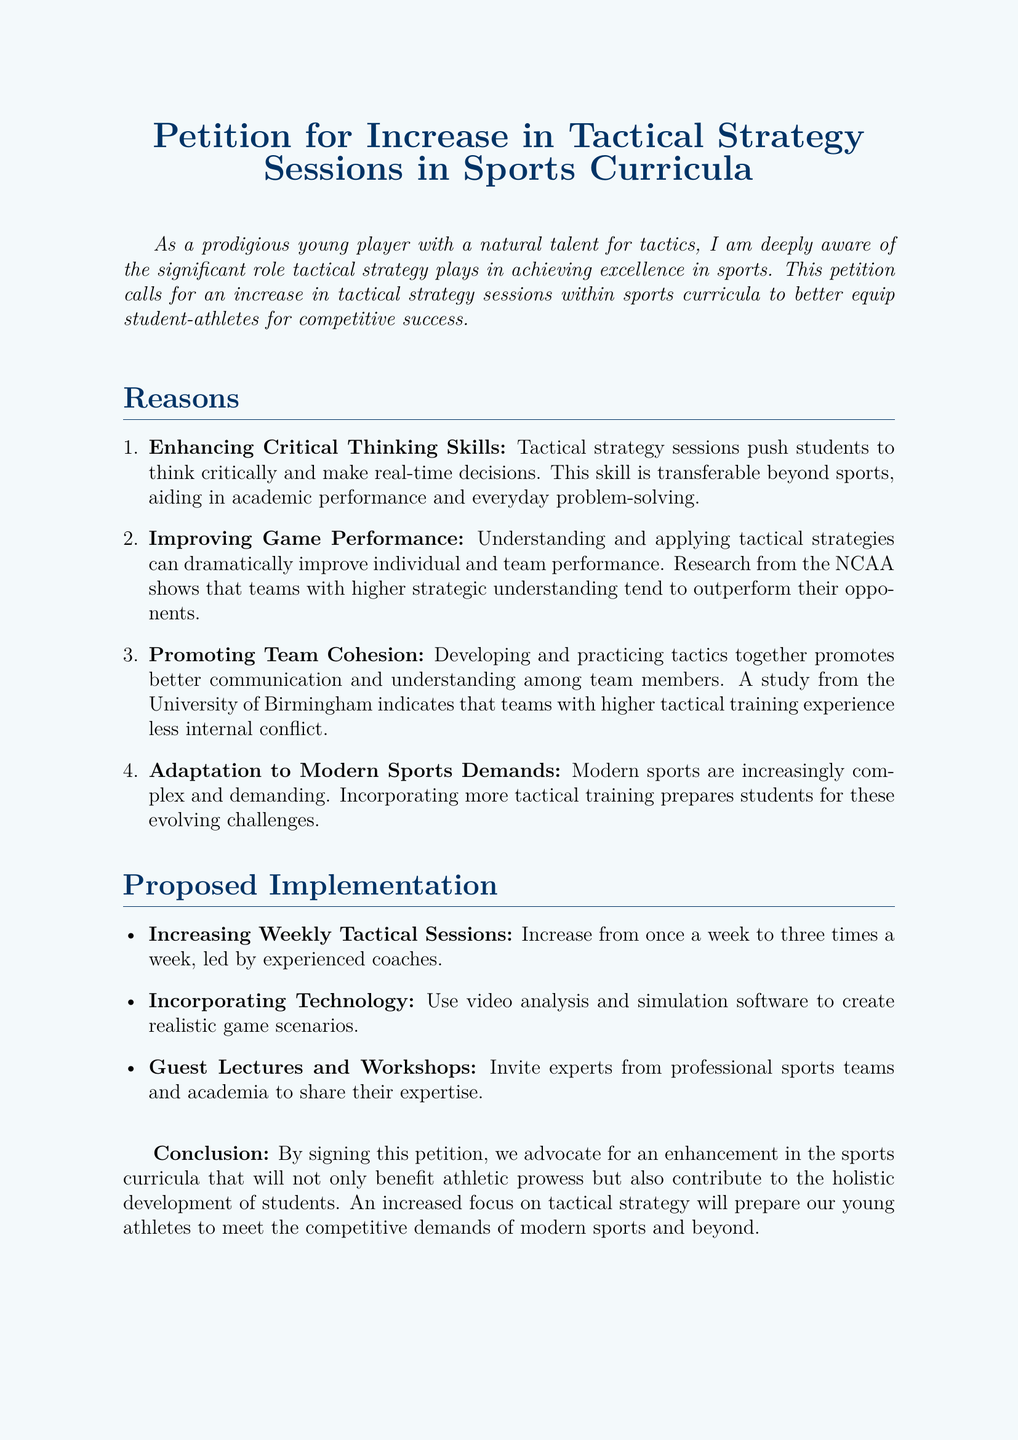What is the title of the petition? The title of the petition is found at the beginning of the document.
Answer: Petition for Increase in Tactical Strategy Sessions in Sports Curricula How many reasons are listed in the petition? The document includes a section that enumerates various reasons for the petition.
Answer: Four What is the primary focus of the proposed implementation? The proposed implementation details are outlined in a specific section of the document.
Answer: Increasing Weekly Tactical Sessions How often does the petition propose to hold tactical strategy sessions? The petition states the frequency proposed for tactical sessions within the text.
Answer: Three times a week Which university is mentioned in the context of team cohesion? A specific university is referenced in the reasons section of the document.
Answer: University of Birmingham What type of analysis is suggested to enhance tactical training? The document proposes a specific form of technology to be used in tactical training.
Answer: Video analysis What is the aim of the petition, as stated in the conclusion? The conclusion summarizes the goal of the petition in a concise manner.
Answer: Enhancement in the sports curricula Who leads the proposed sessions? The document specifies who is responsible for leading the proposed tactical sessions.
Answer: Experienced coaches 